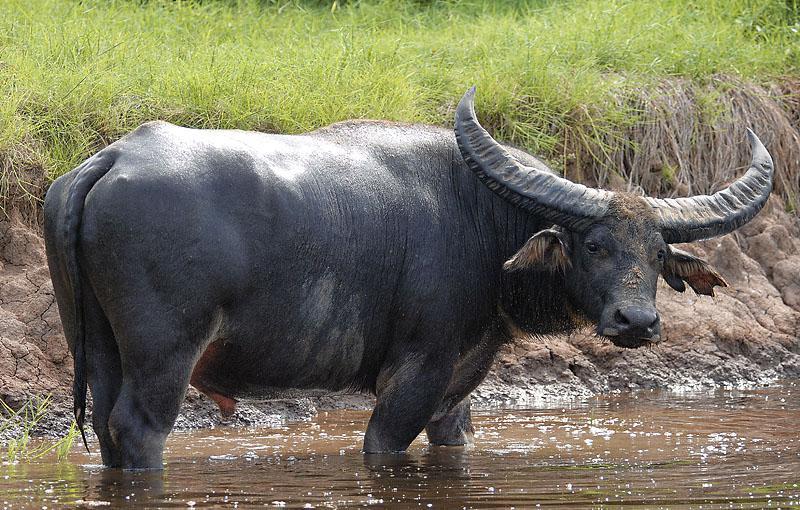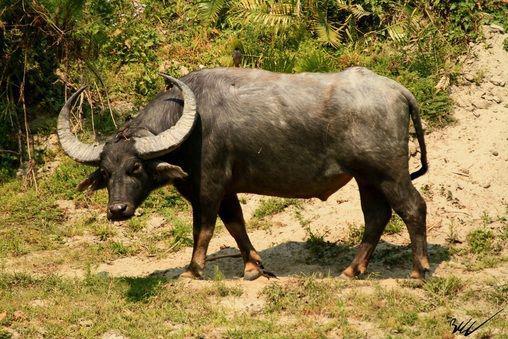The first image is the image on the left, the second image is the image on the right. Analyze the images presented: Is the assertion "Is one of the image there is a water buffalo standing in the water." valid? Answer yes or no. Yes. The first image is the image on the left, the second image is the image on the right. Evaluate the accuracy of this statement regarding the images: "There is a single black buffalo with horns over a foot long facing left in a field of grass.". Is it true? Answer yes or no. Yes. 